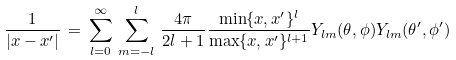<formula> <loc_0><loc_0><loc_500><loc_500>\frac { 1 } { | x - x ^ { \prime } | } \, = \, \sum _ { l = 0 } ^ { \infty } \, \sum _ { m = - l } ^ { l } \, \frac { 4 \pi } { 2 l + 1 } \frac { \min \{ x , x ^ { \prime } \} ^ { l } } { \max \{ x , x ^ { \prime } \} ^ { l + 1 } } Y _ { l m } ( \theta , \phi ) Y _ { l m } ( \theta ^ { \prime } , \phi ^ { \prime } )</formula> 